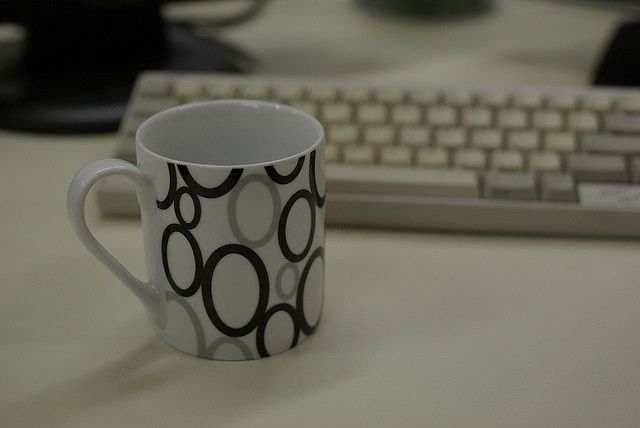Describe the objects in this image and their specific colors. I can see keyboard in black and gray tones and cup in black and gray tones in this image. 